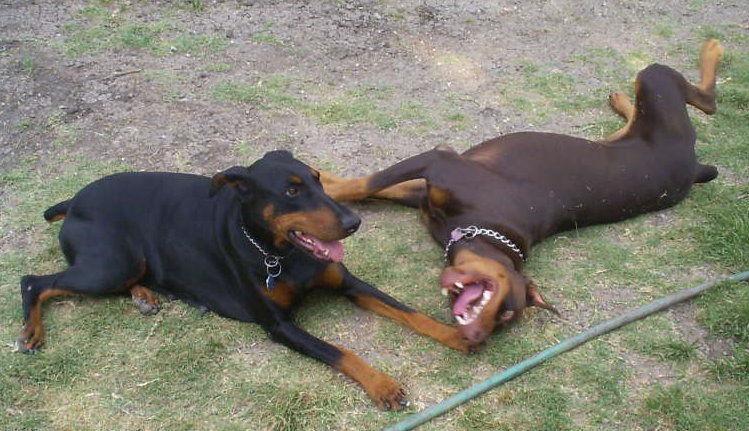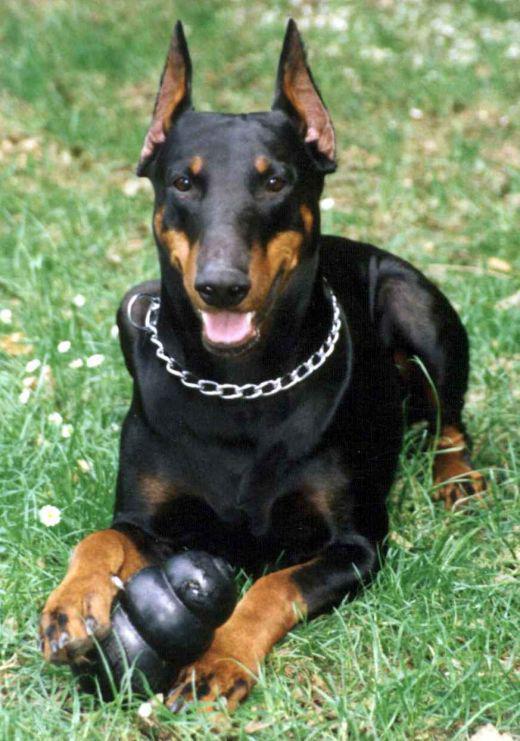The first image is the image on the left, the second image is the image on the right. For the images shown, is this caption "There are an equal number of dogs in each image." true? Answer yes or no. No. The first image is the image on the left, the second image is the image on the right. For the images displayed, is the sentence "Three dogs are present." factually correct? Answer yes or no. Yes. 